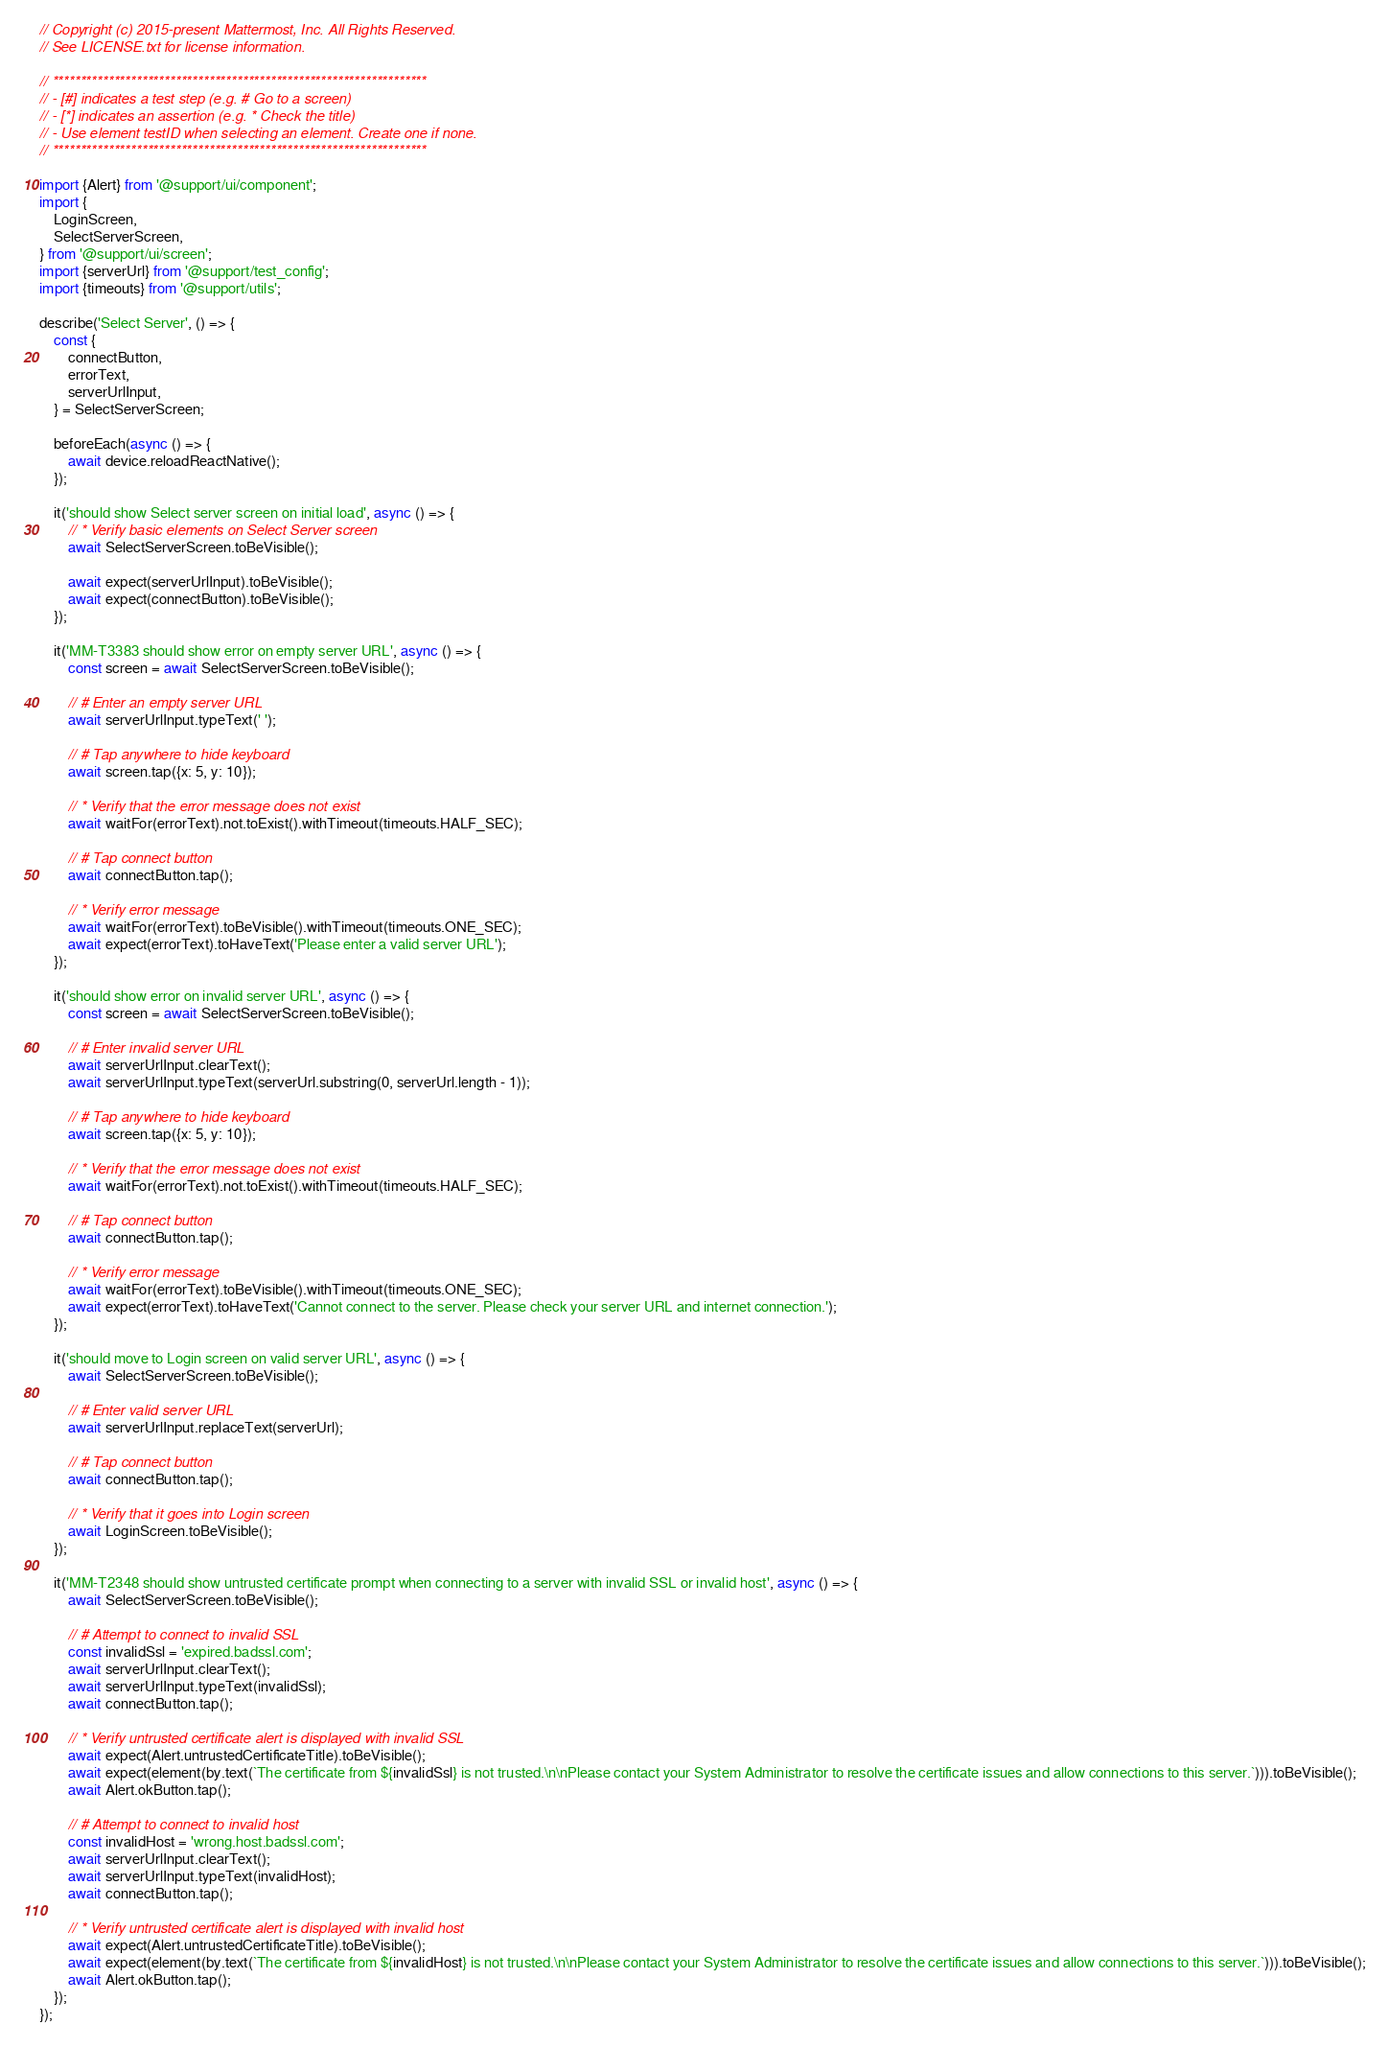<code> <loc_0><loc_0><loc_500><loc_500><_JavaScript_>// Copyright (c) 2015-present Mattermost, Inc. All Rights Reserved.
// See LICENSE.txt for license information.

// *******************************************************************
// - [#] indicates a test step (e.g. # Go to a screen)
// - [*] indicates an assertion (e.g. * Check the title)
// - Use element testID when selecting an element. Create one if none.
// *******************************************************************

import {Alert} from '@support/ui/component';
import {
    LoginScreen,
    SelectServerScreen,
} from '@support/ui/screen';
import {serverUrl} from '@support/test_config';
import {timeouts} from '@support/utils';

describe('Select Server', () => {
    const {
        connectButton,
        errorText,
        serverUrlInput,
    } = SelectServerScreen;

    beforeEach(async () => {
        await device.reloadReactNative();
    });

    it('should show Select server screen on initial load', async () => {
        // * Verify basic elements on Select Server screen
        await SelectServerScreen.toBeVisible();

        await expect(serverUrlInput).toBeVisible();
        await expect(connectButton).toBeVisible();
    });

    it('MM-T3383 should show error on empty server URL', async () => {
        const screen = await SelectServerScreen.toBeVisible();

        // # Enter an empty server URL
        await serverUrlInput.typeText(' ');

        // # Tap anywhere to hide keyboard
        await screen.tap({x: 5, y: 10});

        // * Verify that the error message does not exist
        await waitFor(errorText).not.toExist().withTimeout(timeouts.HALF_SEC);

        // # Tap connect button
        await connectButton.tap();

        // * Verify error message
        await waitFor(errorText).toBeVisible().withTimeout(timeouts.ONE_SEC);
        await expect(errorText).toHaveText('Please enter a valid server URL');
    });

    it('should show error on invalid server URL', async () => {
        const screen = await SelectServerScreen.toBeVisible();

        // # Enter invalid server URL
        await serverUrlInput.clearText();
        await serverUrlInput.typeText(serverUrl.substring(0, serverUrl.length - 1));

        // # Tap anywhere to hide keyboard
        await screen.tap({x: 5, y: 10});

        // * Verify that the error message does not exist
        await waitFor(errorText).not.toExist().withTimeout(timeouts.HALF_SEC);

        // # Tap connect button
        await connectButton.tap();

        // * Verify error message
        await waitFor(errorText).toBeVisible().withTimeout(timeouts.ONE_SEC);
        await expect(errorText).toHaveText('Cannot connect to the server. Please check your server URL and internet connection.');
    });

    it('should move to Login screen on valid server URL', async () => {
        await SelectServerScreen.toBeVisible();

        // # Enter valid server URL
        await serverUrlInput.replaceText(serverUrl);

        // # Tap connect button
        await connectButton.tap();

        // * Verify that it goes into Login screen
        await LoginScreen.toBeVisible();
    });

    it('MM-T2348 should show untrusted certificate prompt when connecting to a server with invalid SSL or invalid host', async () => {
        await SelectServerScreen.toBeVisible();

        // # Attempt to connect to invalid SSL
        const invalidSsl = 'expired.badssl.com';
        await serverUrlInput.clearText();
        await serverUrlInput.typeText(invalidSsl);
        await connectButton.tap();

        // * Verify untrusted certificate alert is displayed with invalid SSL
        await expect(Alert.untrustedCertificateTitle).toBeVisible();
        await expect(element(by.text(`The certificate from ${invalidSsl} is not trusted.\n\nPlease contact your System Administrator to resolve the certificate issues and allow connections to this server.`))).toBeVisible();
        await Alert.okButton.tap();

        // # Attempt to connect to invalid host
        const invalidHost = 'wrong.host.badssl.com';
        await serverUrlInput.clearText();
        await serverUrlInput.typeText(invalidHost);
        await connectButton.tap();

        // * Verify untrusted certificate alert is displayed with invalid host
        await expect(Alert.untrustedCertificateTitle).toBeVisible();
        await expect(element(by.text(`The certificate from ${invalidHost} is not trusted.\n\nPlease contact your System Administrator to resolve the certificate issues and allow connections to this server.`))).toBeVisible();
        await Alert.okButton.tap();
    });
});
</code> 